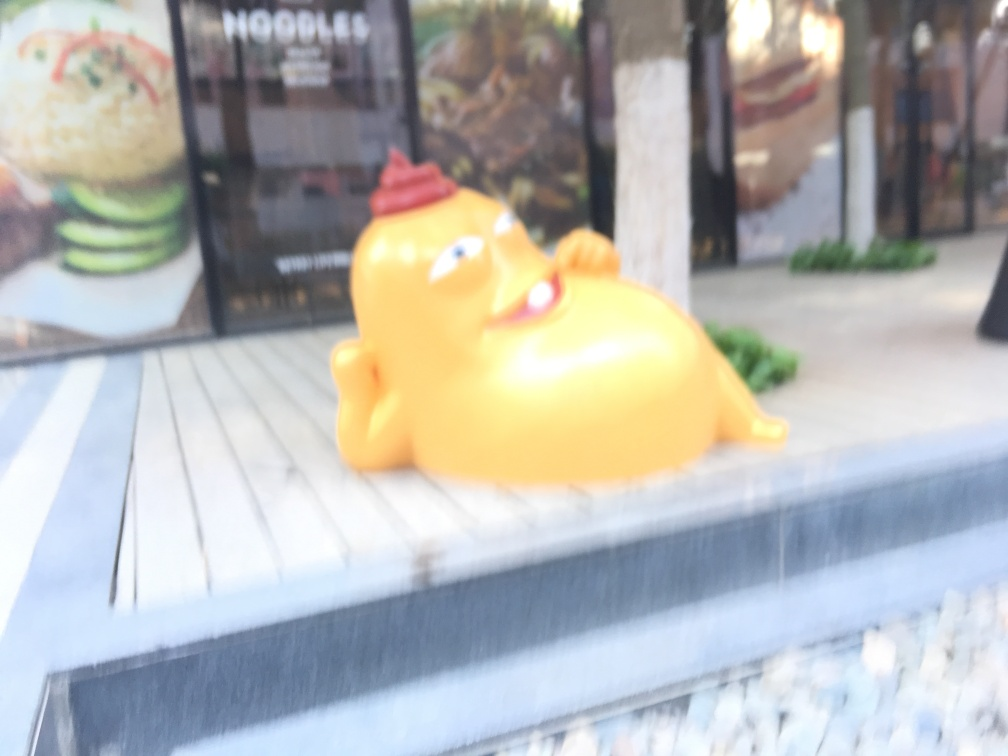Could you describe the blur effect seen in this photo? Certainly, the blur effect in this image is quite prominent, causing the scene and the figurine to appear out of focus. This could be the result of a camera's shallow depth of field or an intentional motion blur, creating an artistic or dreamy quality to the photo. It emphasizes the subject by obscuring the background and drawing the viewer's attention to the form and color of the object rather than its details. 